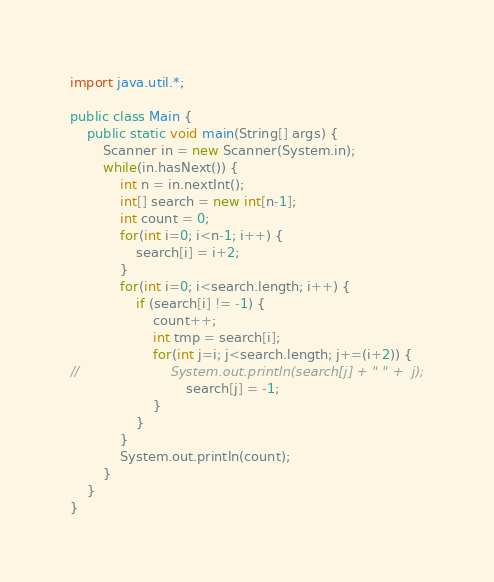Convert code to text. <code><loc_0><loc_0><loc_500><loc_500><_Java_>import java.util.*;

public class Main {
	public static void main(String[] args) {
		Scanner in = new Scanner(System.in);
		while(in.hasNext()) {
			int n = in.nextInt();
			int[] search = new int[n-1];
			int count = 0;
			for(int i=0; i<n-1; i++) {
				search[i] = i+2;
			}
			for(int i=0; i<search.length; i++) {
				if (search[i] != -1) {
					count++;
					int tmp = search[i];
					for(int j=i; j<search.length; j+=(i+2)) {
//						System.out.println(search[j] + " " +  j);
							search[j] = -1;
					}
				}
			}
			System.out.println(count);
		}
	}
}</code> 